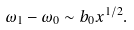Convert formula to latex. <formula><loc_0><loc_0><loc_500><loc_500>\omega _ { 1 } - \omega _ { 0 } \sim b _ { 0 } x ^ { 1 / 2 } .</formula> 